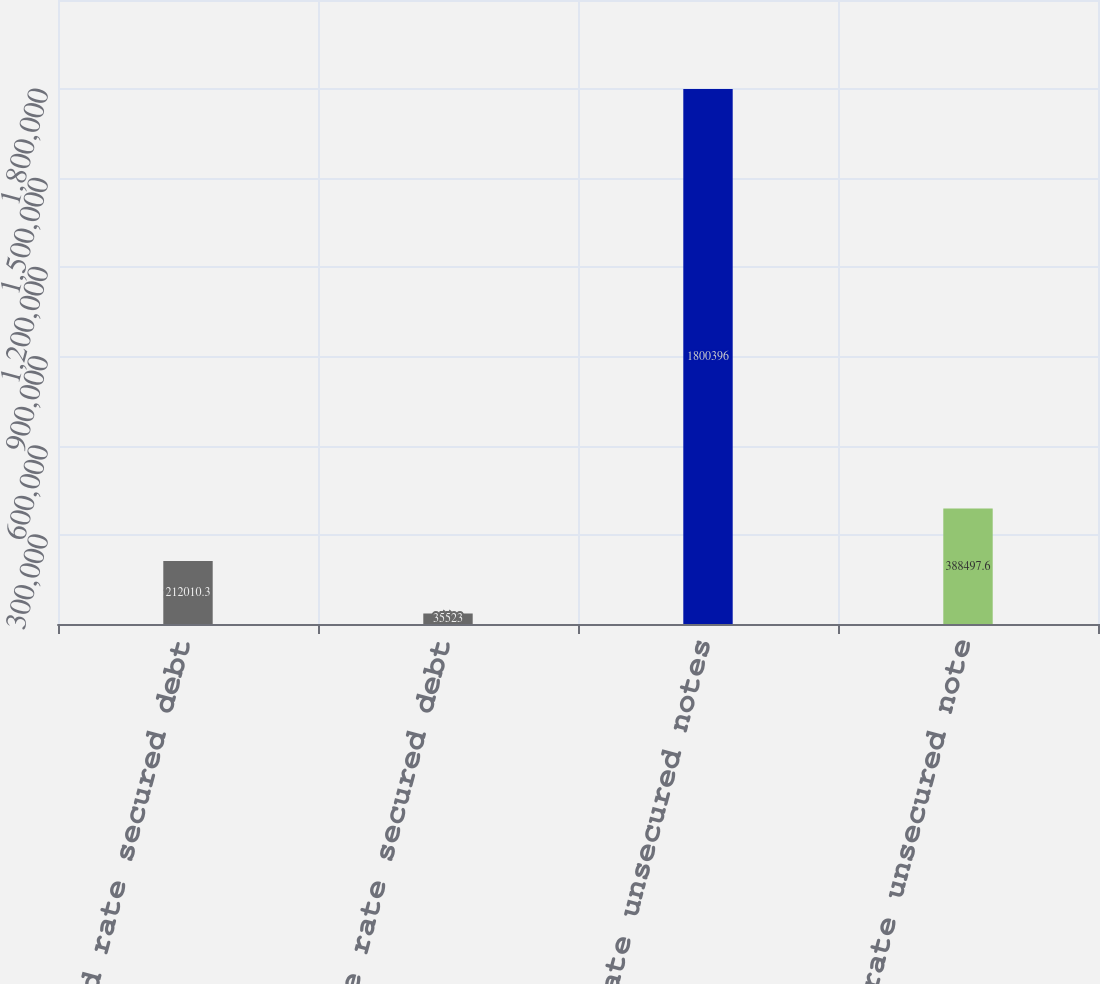Convert chart. <chart><loc_0><loc_0><loc_500><loc_500><bar_chart><fcel>Fixed rate secured debt<fcel>Variable rate secured debt<fcel>Fixed rate unsecured notes<fcel>Variable rate unsecured note<nl><fcel>212010<fcel>35523<fcel>1.8004e+06<fcel>388498<nl></chart> 